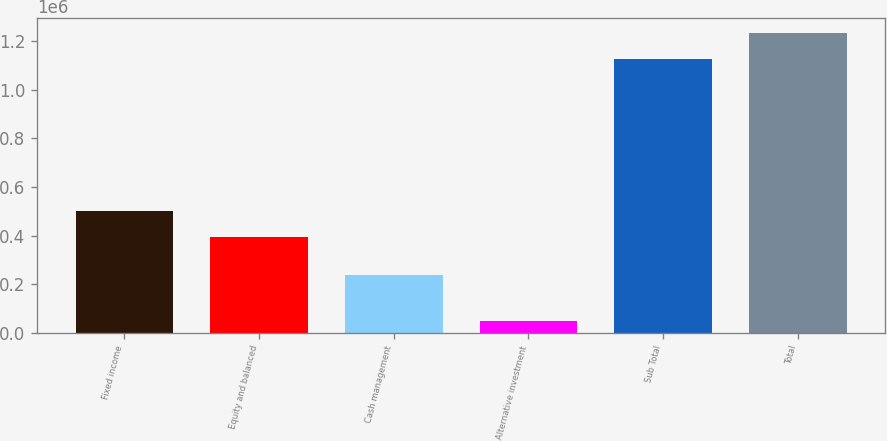<chart> <loc_0><loc_0><loc_500><loc_500><bar_chart><fcel>Fixed income<fcel>Equity and balanced<fcel>Cash management<fcel>Alternative investment<fcel>Sub Total<fcel>Total<nl><fcel>500357<fcel>392708<fcel>235768<fcel>48139<fcel>1.12463e+06<fcel>1.23228e+06<nl></chart> 